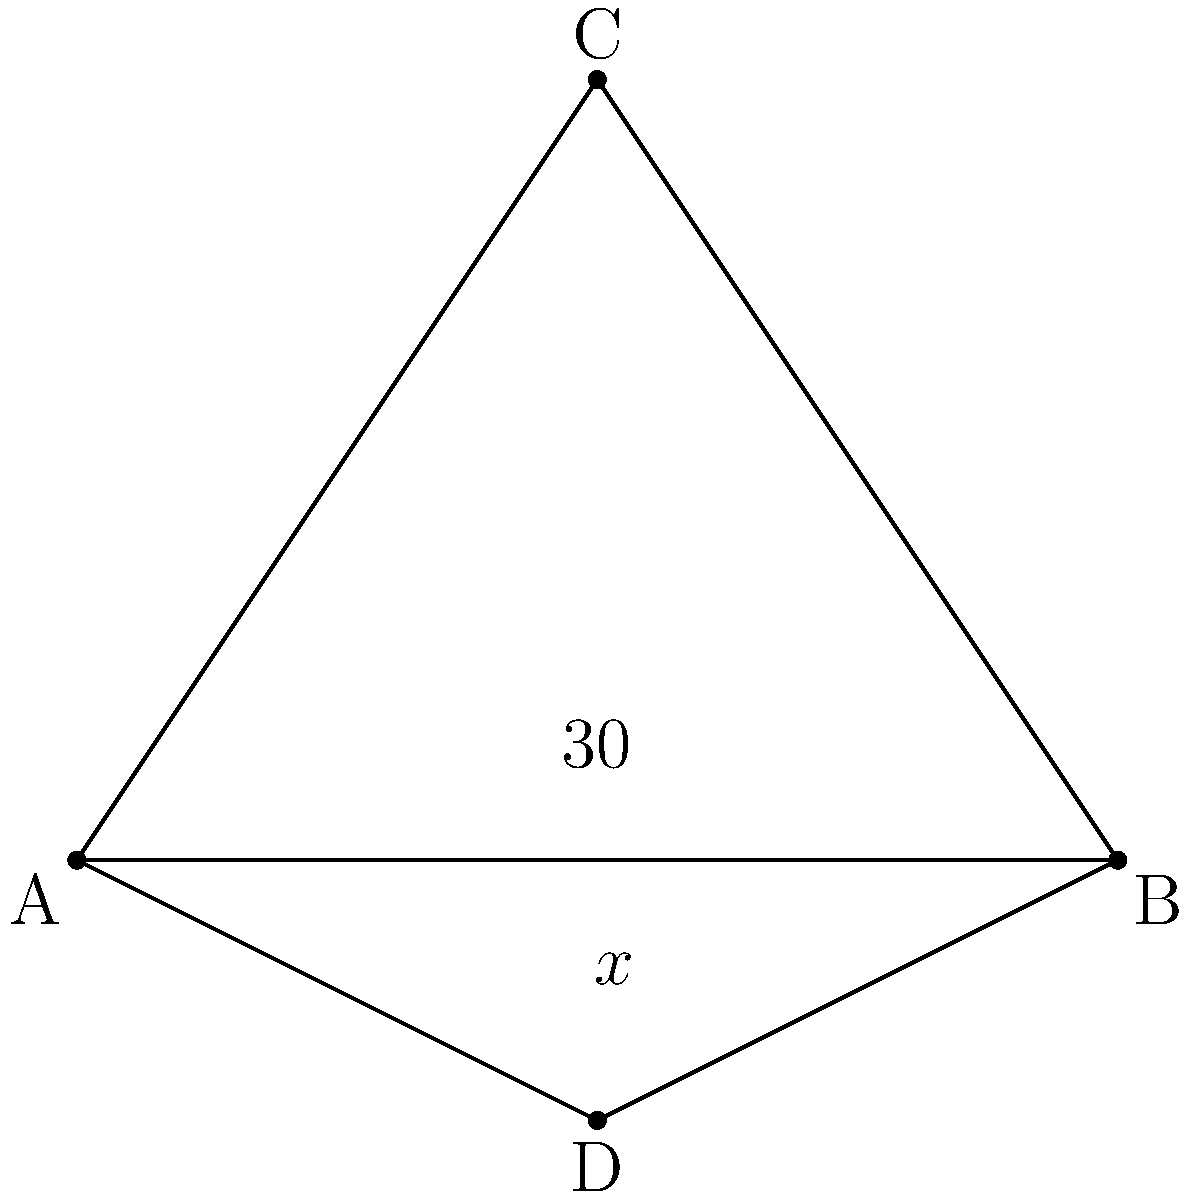In the technical drawing above, lines AC and BD intersect at point E. Given that angle AEB is 30°, what is the value of angle CED (represented by x°)? To solve this problem, we'll use the properties of intersecting lines and supplementary angles:

1. When two lines intersect, they form two pairs of vertical angles. Vertical angles are always congruent.

2. The sum of the angles on a straight line is 180°.

3. In this case, angle AEB and angle CED are vertical angles, so they are congruent.

4. Angle AEB + angle BEC = 180° (they form a straight line)

5. We're given that angle AEB = 30°

6. Therefore, angle BEC = 180° - 30° = 150°

7. Since angle CED is vertical to angle AEB, they are congruent:
   angle CED = angle AEB = 30°

Thus, x° = 30°.
Answer: $30°$ 